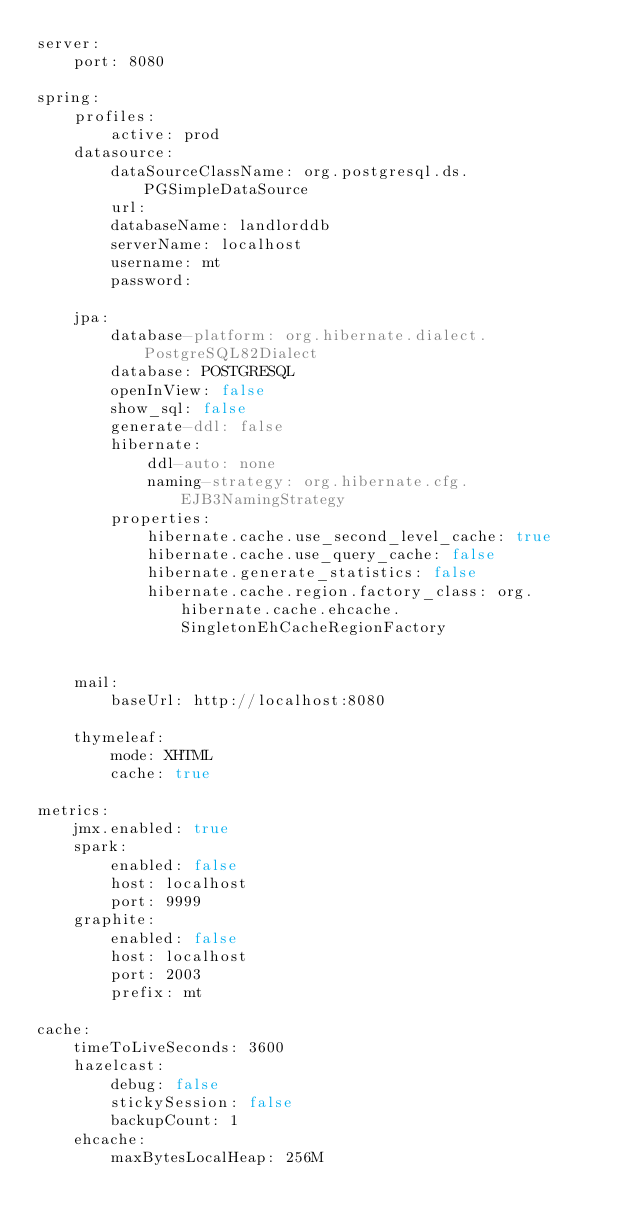Convert code to text. <code><loc_0><loc_0><loc_500><loc_500><_YAML_>server:
    port: 8080

spring:
    profiles:
        active: prod
    datasource:
        dataSourceClassName: org.postgresql.ds.PGSimpleDataSource
        url:
        databaseName: landlorddb
        serverName: localhost
        username: mt
        password:

    jpa:
        database-platform: org.hibernate.dialect.PostgreSQL82Dialect
        database: POSTGRESQL
        openInView: false
        show_sql: false
        generate-ddl: false
        hibernate:
            ddl-auto: none
            naming-strategy: org.hibernate.cfg.EJB3NamingStrategy
        properties:
            hibernate.cache.use_second_level_cache: true
            hibernate.cache.use_query_cache: false
            hibernate.generate_statistics: false
            hibernate.cache.region.factory_class: org.hibernate.cache.ehcache.SingletonEhCacheRegionFactory


    mail:
        baseUrl: http://localhost:8080

    thymeleaf:
        mode: XHTML
        cache: true

metrics:
    jmx.enabled: true
    spark:
        enabled: false
        host: localhost
        port: 9999
    graphite:
        enabled: false
        host: localhost
        port: 2003
        prefix: mt

cache:
    timeToLiveSeconds: 3600
    hazelcast:
        debug: false
        stickySession: false
        backupCount: 1
    ehcache:
        maxBytesLocalHeap: 256M
</code> 